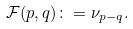Convert formula to latex. <formula><loc_0><loc_0><loc_500><loc_500>\mathcal { F } ( p , q ) \colon = \nu _ { p - q } .</formula> 